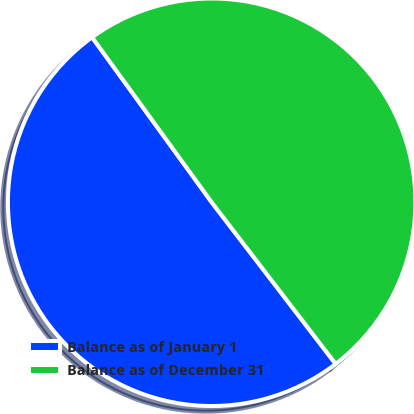<chart> <loc_0><loc_0><loc_500><loc_500><pie_chart><fcel>Balance as of January 1<fcel>Balance as of December 31<nl><fcel>50.43%<fcel>49.57%<nl></chart> 